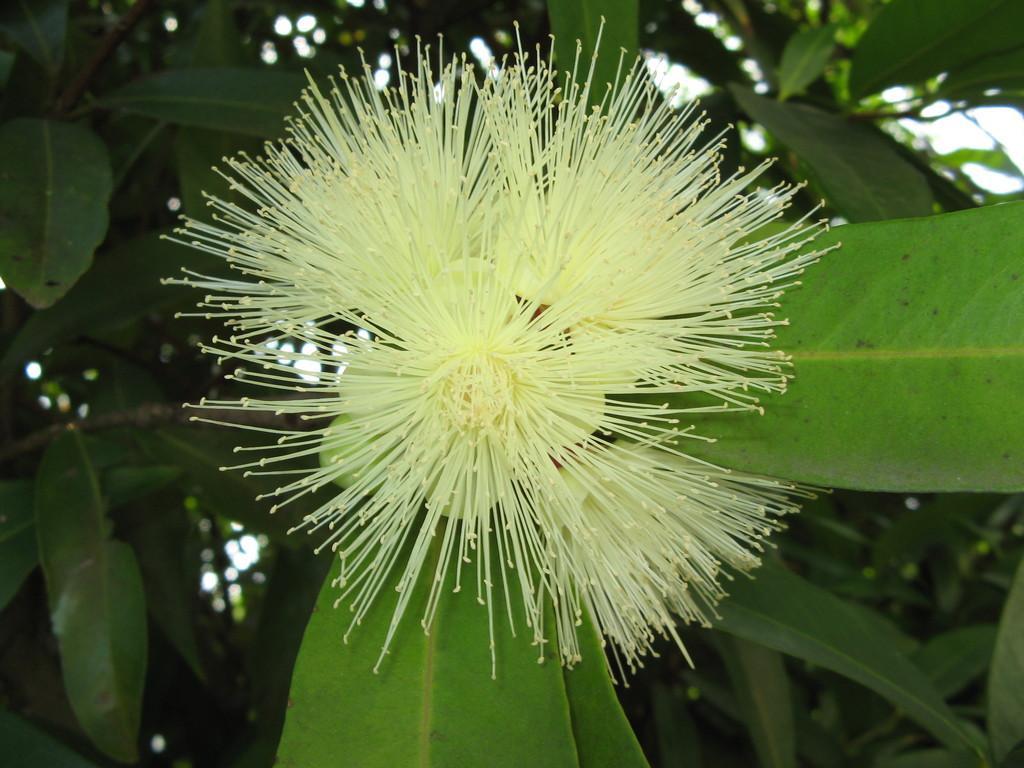Describe this image in one or two sentences. This image consists of a plant. There is a flower in green color. In the background, there are leaves. 